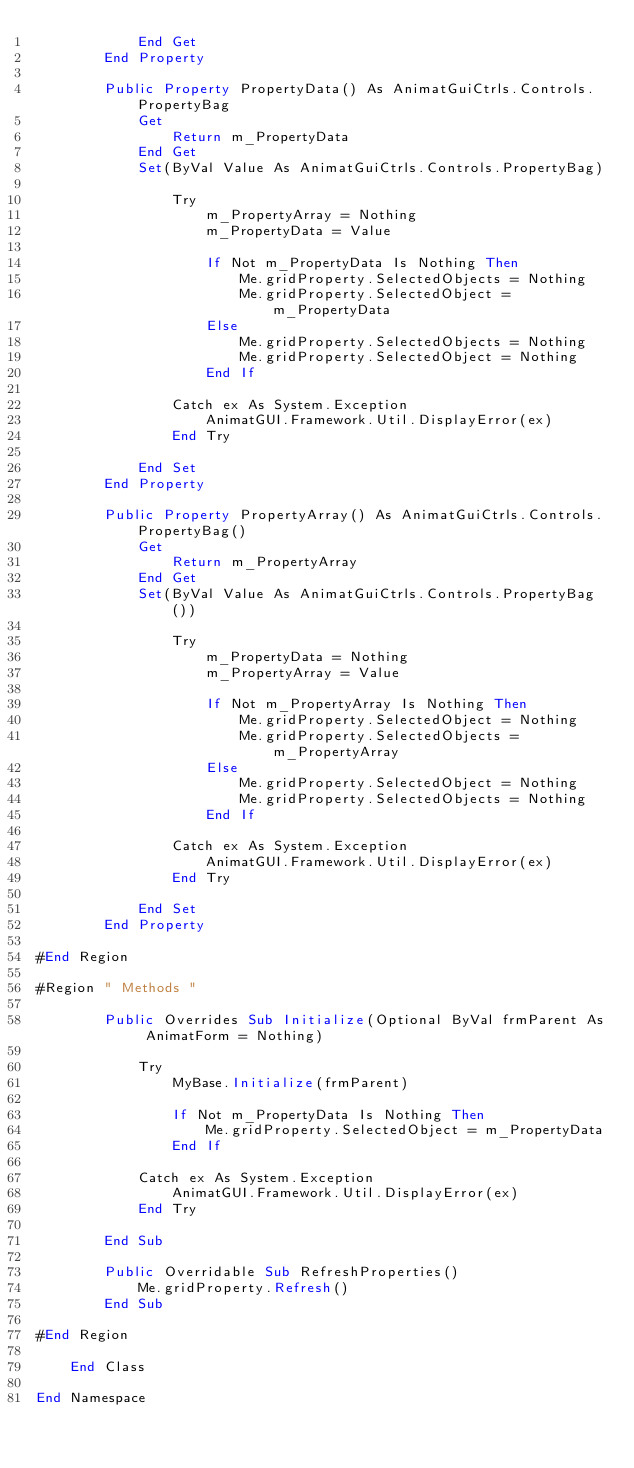<code> <loc_0><loc_0><loc_500><loc_500><_VisualBasic_>            End Get
        End Property

        Public Property PropertyData() As AnimatGuiCtrls.Controls.PropertyBag
            Get
                Return m_PropertyData
            End Get
            Set(ByVal Value As AnimatGuiCtrls.Controls.PropertyBag)

                Try
                    m_PropertyArray = Nothing
                    m_PropertyData = Value

                    If Not m_PropertyData Is Nothing Then
                        Me.gridProperty.SelectedObjects = Nothing
                        Me.gridProperty.SelectedObject = m_PropertyData
                    Else
                        Me.gridProperty.SelectedObjects = Nothing
                        Me.gridProperty.SelectedObject = Nothing
                    End If

                Catch ex As System.Exception
                    AnimatGUI.Framework.Util.DisplayError(ex)
                End Try

            End Set
        End Property

        Public Property PropertyArray() As AnimatGuiCtrls.Controls.PropertyBag()
            Get
                Return m_PropertyArray
            End Get
            Set(ByVal Value As AnimatGuiCtrls.Controls.PropertyBag())

                Try
                    m_PropertyData = Nothing
                    m_PropertyArray = Value

                    If Not m_PropertyArray Is Nothing Then
                        Me.gridProperty.SelectedObject = Nothing
                        Me.gridProperty.SelectedObjects = m_PropertyArray
                    Else
                        Me.gridProperty.SelectedObject = Nothing
                        Me.gridProperty.SelectedObjects = Nothing
                    End If

                Catch ex As System.Exception
                    AnimatGUI.Framework.Util.DisplayError(ex)
                End Try

            End Set
        End Property

#End Region

#Region " Methods "

        Public Overrides Sub Initialize(Optional ByVal frmParent As AnimatForm = Nothing)

            Try
                MyBase.Initialize(frmParent)

                If Not m_PropertyData Is Nothing Then
                    Me.gridProperty.SelectedObject = m_PropertyData
                End If

            Catch ex As System.Exception
                AnimatGUI.Framework.Util.DisplayError(ex)
            End Try

        End Sub

        Public Overridable Sub RefreshProperties()
            Me.gridProperty.Refresh()
        End Sub

#End Region

    End Class

End Namespace</code> 